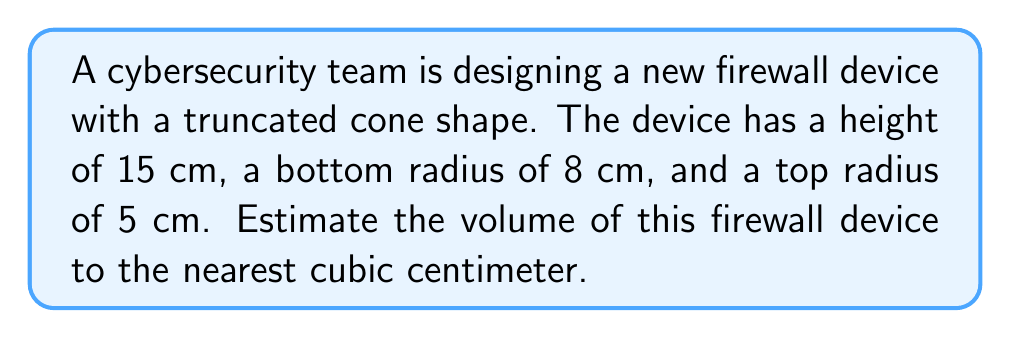Could you help me with this problem? To solve this problem, we'll use the formula for the volume of a truncated cone:

$$V = \frac{1}{3}\pi h(R^2 + r^2 + Rr)$$

Where:
$V$ = volume
$h$ = height
$R$ = radius of the base
$r$ = radius of the top

Given:
$h = 15$ cm
$R = 8$ cm
$r = 5$ cm

Let's substitute these values into the formula:

$$V = \frac{1}{3}\pi \cdot 15(8^2 + 5^2 + 8 \cdot 5)$$

Simplify:
$$V = 5\pi(64 + 25 + 40)$$
$$V = 5\pi(129)$$
$$V = 645\pi$$

Calculate:
$$V \approx 2026.83 \text{ cm}^3$$

Rounding to the nearest cubic centimeter:
$$V \approx 2027 \text{ cm}^3$$
Answer: 2027 cm³ 